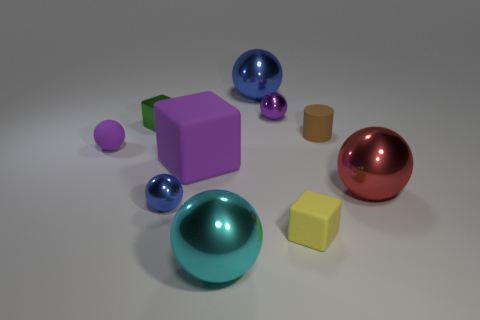Is the number of rubber objects in front of the big red sphere the same as the number of rubber cubes that are in front of the cyan ball?
Ensure brevity in your answer.  No. Does the cylinder have the same size as the blue ball that is to the left of the big blue sphere?
Your answer should be very brief. Yes. Are there any tiny yellow rubber cubes that are behind the tiny purple object that is on the right side of the cyan object?
Ensure brevity in your answer.  No. Is there another rubber thing that has the same shape as the big blue thing?
Offer a very short reply. Yes. What number of tiny yellow cubes are in front of the small metal sphere that is right of the blue shiny sphere that is behind the small green block?
Provide a succinct answer. 1. There is a matte cylinder; is it the same color as the large metallic sphere to the right of the cylinder?
Provide a succinct answer. No. What number of things are either blue things that are to the right of the large cyan metal ball or things that are in front of the small green metallic object?
Make the answer very short. 8. Are there more metal objects that are on the left side of the green thing than small yellow things on the left side of the big cyan shiny object?
Provide a succinct answer. No. There is a small purple ball to the left of the small purple ball that is behind the tiny purple object that is in front of the green thing; what is its material?
Provide a short and direct response. Rubber. There is a big metallic object behind the big purple matte object; does it have the same shape as the purple rubber object behind the large purple block?
Make the answer very short. Yes. 